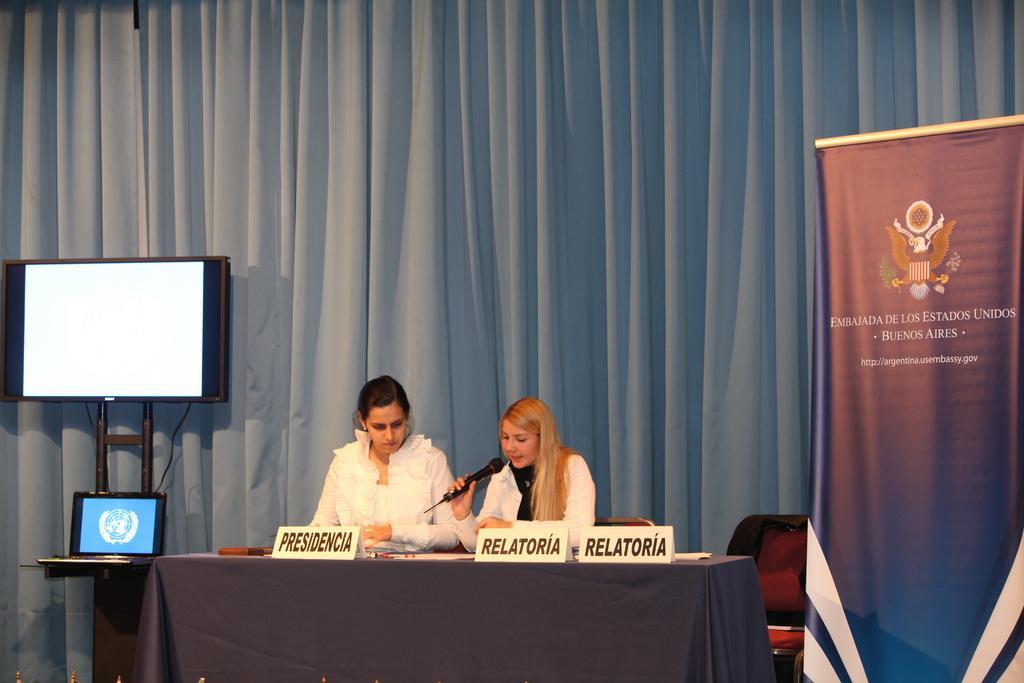Could you give a brief overview of what you see in this image? In this image there are two people sitting on the chair. In front of them there is a table. On top of it there are name boards with some text on it and a there are a few other objects. Beside them there is another chair. There is a banner. On the left side of the image there is a laptop on the table. There is a TV. In the background of the image there are curtains. 